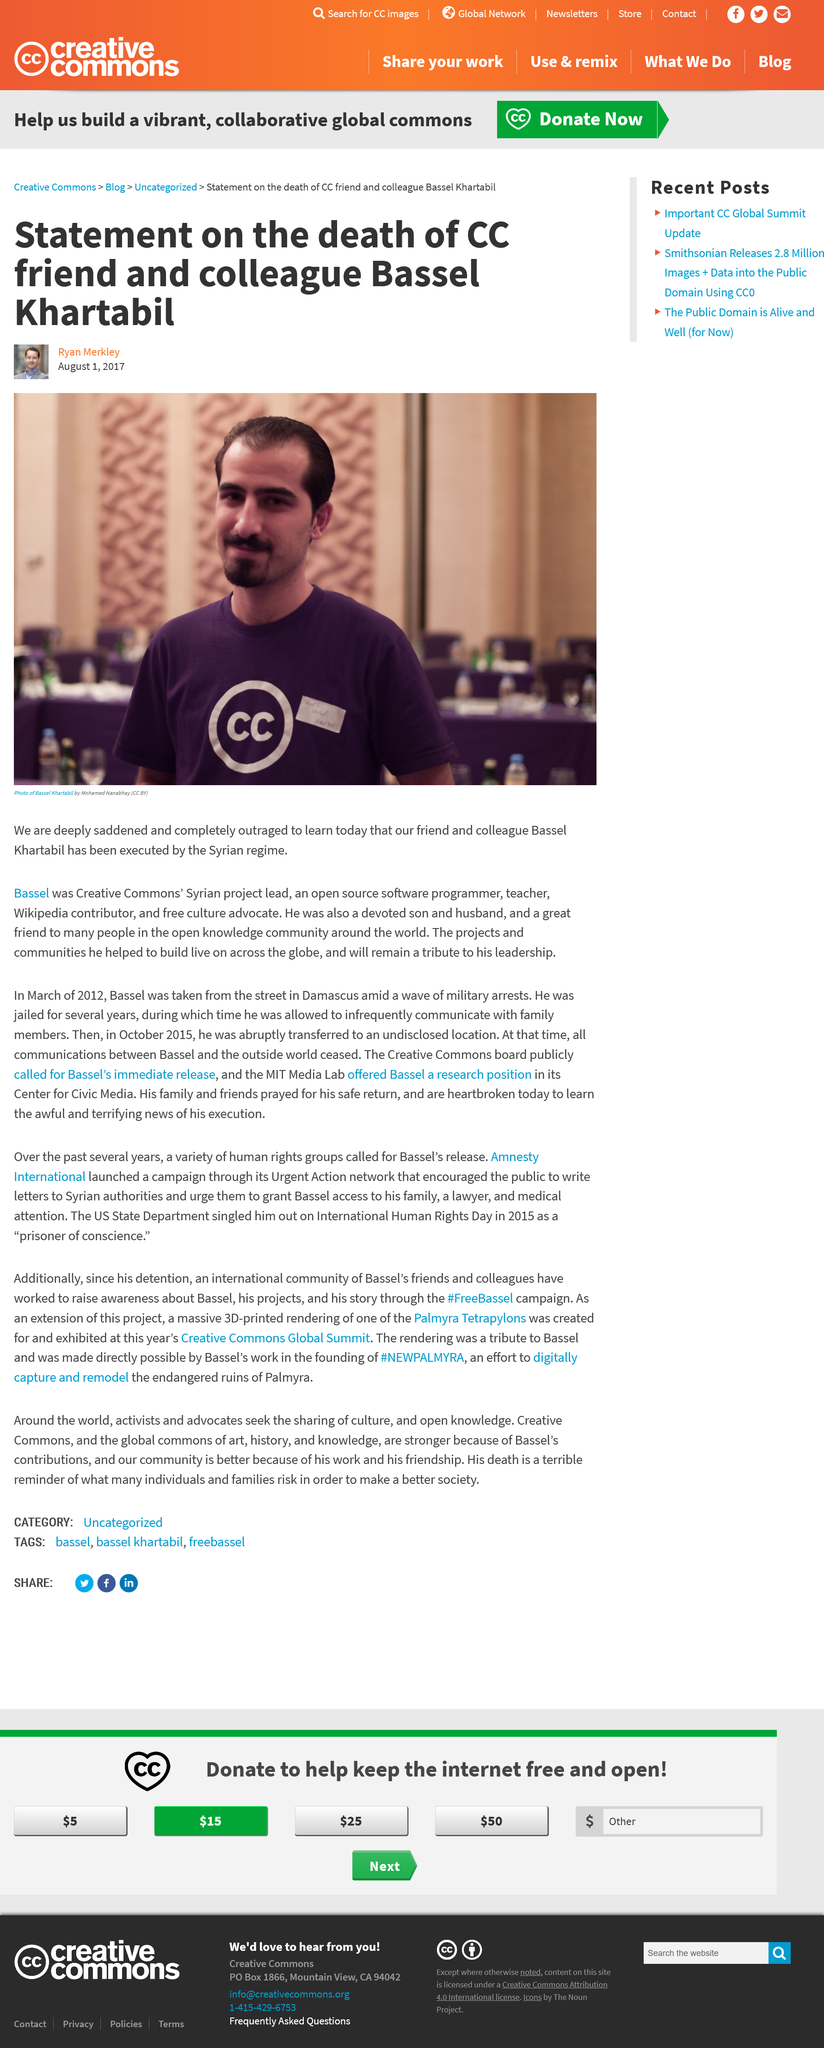Highlight a few significant elements in this photo. Bassel Khartabil was an advocate for free culture. He believed in the power of open access to information and the importance of sharing knowledge without restriction. Bassel Khartabil worked for Creative Commons. Bassel Khartabil was executed by the Syrian regime. 